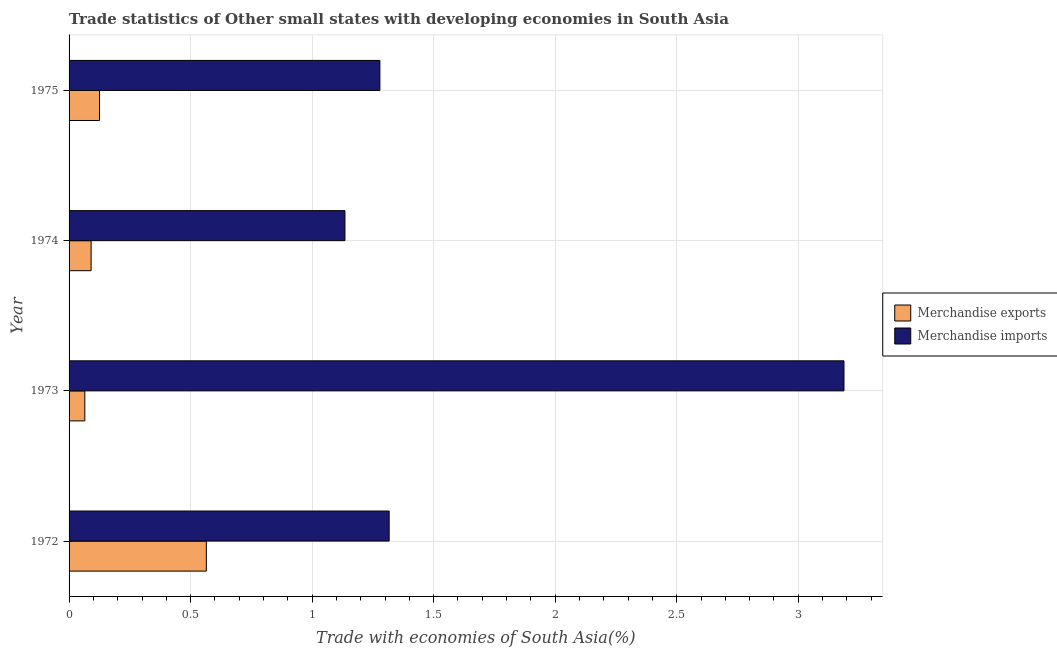How many different coloured bars are there?
Make the answer very short. 2. How many groups of bars are there?
Your response must be concise. 4. Are the number of bars per tick equal to the number of legend labels?
Ensure brevity in your answer.  Yes. How many bars are there on the 4th tick from the bottom?
Offer a terse response. 2. What is the label of the 2nd group of bars from the top?
Ensure brevity in your answer.  1974. In how many cases, is the number of bars for a given year not equal to the number of legend labels?
Provide a succinct answer. 0. What is the merchandise exports in 1973?
Provide a succinct answer. 0.06. Across all years, what is the maximum merchandise imports?
Provide a succinct answer. 3.19. Across all years, what is the minimum merchandise exports?
Make the answer very short. 0.06. In which year was the merchandise exports minimum?
Keep it short and to the point. 1973. What is the total merchandise exports in the graph?
Provide a short and direct response. 0.85. What is the difference between the merchandise imports in 1973 and that in 1974?
Make the answer very short. 2.05. What is the difference between the merchandise imports in 1974 and the merchandise exports in 1972?
Your answer should be very brief. 0.57. What is the average merchandise imports per year?
Give a very brief answer. 1.73. In the year 1974, what is the difference between the merchandise exports and merchandise imports?
Give a very brief answer. -1.04. In how many years, is the merchandise imports greater than 1.5 %?
Provide a succinct answer. 1. What is the ratio of the merchandise imports in 1974 to that in 1975?
Your answer should be very brief. 0.89. Is the difference between the merchandise imports in 1972 and 1973 greater than the difference between the merchandise exports in 1972 and 1973?
Provide a short and direct response. No. What is the difference between the highest and the second highest merchandise imports?
Keep it short and to the point. 1.87. What is the difference between the highest and the lowest merchandise imports?
Offer a very short reply. 2.05. Is the sum of the merchandise exports in 1972 and 1975 greater than the maximum merchandise imports across all years?
Offer a very short reply. No. What does the 1st bar from the top in 1975 represents?
Keep it short and to the point. Merchandise imports. How many bars are there?
Keep it short and to the point. 8. Are all the bars in the graph horizontal?
Your answer should be compact. Yes. How many years are there in the graph?
Give a very brief answer. 4. Does the graph contain any zero values?
Provide a succinct answer. No. Does the graph contain grids?
Ensure brevity in your answer.  Yes. How are the legend labels stacked?
Give a very brief answer. Vertical. What is the title of the graph?
Offer a terse response. Trade statistics of Other small states with developing economies in South Asia. Does "Broad money growth" appear as one of the legend labels in the graph?
Your answer should be very brief. No. What is the label or title of the X-axis?
Offer a terse response. Trade with economies of South Asia(%). What is the label or title of the Y-axis?
Keep it short and to the point. Year. What is the Trade with economies of South Asia(%) of Merchandise exports in 1972?
Provide a short and direct response. 0.56. What is the Trade with economies of South Asia(%) in Merchandise imports in 1972?
Your answer should be compact. 1.32. What is the Trade with economies of South Asia(%) of Merchandise exports in 1973?
Offer a very short reply. 0.06. What is the Trade with economies of South Asia(%) of Merchandise imports in 1973?
Make the answer very short. 3.19. What is the Trade with economies of South Asia(%) in Merchandise exports in 1974?
Your answer should be very brief. 0.09. What is the Trade with economies of South Asia(%) of Merchandise imports in 1974?
Offer a terse response. 1.13. What is the Trade with economies of South Asia(%) in Merchandise exports in 1975?
Your response must be concise. 0.13. What is the Trade with economies of South Asia(%) of Merchandise imports in 1975?
Your response must be concise. 1.28. Across all years, what is the maximum Trade with economies of South Asia(%) in Merchandise exports?
Provide a succinct answer. 0.56. Across all years, what is the maximum Trade with economies of South Asia(%) in Merchandise imports?
Offer a terse response. 3.19. Across all years, what is the minimum Trade with economies of South Asia(%) in Merchandise exports?
Offer a very short reply. 0.06. Across all years, what is the minimum Trade with economies of South Asia(%) in Merchandise imports?
Your answer should be compact. 1.13. What is the total Trade with economies of South Asia(%) in Merchandise exports in the graph?
Offer a terse response. 0.85. What is the total Trade with economies of South Asia(%) in Merchandise imports in the graph?
Your answer should be very brief. 6.92. What is the difference between the Trade with economies of South Asia(%) in Merchandise imports in 1972 and that in 1973?
Offer a terse response. -1.87. What is the difference between the Trade with economies of South Asia(%) of Merchandise exports in 1972 and that in 1974?
Your answer should be compact. 0.47. What is the difference between the Trade with economies of South Asia(%) of Merchandise imports in 1972 and that in 1974?
Your answer should be very brief. 0.18. What is the difference between the Trade with economies of South Asia(%) in Merchandise exports in 1972 and that in 1975?
Your response must be concise. 0.44. What is the difference between the Trade with economies of South Asia(%) in Merchandise imports in 1972 and that in 1975?
Your answer should be compact. 0.04. What is the difference between the Trade with economies of South Asia(%) of Merchandise exports in 1973 and that in 1974?
Ensure brevity in your answer.  -0.03. What is the difference between the Trade with economies of South Asia(%) of Merchandise imports in 1973 and that in 1974?
Your answer should be very brief. 2.05. What is the difference between the Trade with economies of South Asia(%) in Merchandise exports in 1973 and that in 1975?
Make the answer very short. -0.06. What is the difference between the Trade with economies of South Asia(%) in Merchandise imports in 1973 and that in 1975?
Ensure brevity in your answer.  1.91. What is the difference between the Trade with economies of South Asia(%) in Merchandise exports in 1974 and that in 1975?
Provide a succinct answer. -0.03. What is the difference between the Trade with economies of South Asia(%) in Merchandise imports in 1974 and that in 1975?
Your answer should be very brief. -0.14. What is the difference between the Trade with economies of South Asia(%) in Merchandise exports in 1972 and the Trade with economies of South Asia(%) in Merchandise imports in 1973?
Offer a very short reply. -2.62. What is the difference between the Trade with economies of South Asia(%) in Merchandise exports in 1972 and the Trade with economies of South Asia(%) in Merchandise imports in 1974?
Provide a succinct answer. -0.57. What is the difference between the Trade with economies of South Asia(%) of Merchandise exports in 1972 and the Trade with economies of South Asia(%) of Merchandise imports in 1975?
Make the answer very short. -0.71. What is the difference between the Trade with economies of South Asia(%) in Merchandise exports in 1973 and the Trade with economies of South Asia(%) in Merchandise imports in 1974?
Your answer should be very brief. -1.07. What is the difference between the Trade with economies of South Asia(%) in Merchandise exports in 1973 and the Trade with economies of South Asia(%) in Merchandise imports in 1975?
Your response must be concise. -1.21. What is the difference between the Trade with economies of South Asia(%) of Merchandise exports in 1974 and the Trade with economies of South Asia(%) of Merchandise imports in 1975?
Keep it short and to the point. -1.19. What is the average Trade with economies of South Asia(%) of Merchandise exports per year?
Offer a terse response. 0.21. What is the average Trade with economies of South Asia(%) of Merchandise imports per year?
Your answer should be very brief. 1.73. In the year 1972, what is the difference between the Trade with economies of South Asia(%) of Merchandise exports and Trade with economies of South Asia(%) of Merchandise imports?
Provide a short and direct response. -0.75. In the year 1973, what is the difference between the Trade with economies of South Asia(%) in Merchandise exports and Trade with economies of South Asia(%) in Merchandise imports?
Offer a very short reply. -3.12. In the year 1974, what is the difference between the Trade with economies of South Asia(%) in Merchandise exports and Trade with economies of South Asia(%) in Merchandise imports?
Ensure brevity in your answer.  -1.04. In the year 1975, what is the difference between the Trade with economies of South Asia(%) of Merchandise exports and Trade with economies of South Asia(%) of Merchandise imports?
Provide a succinct answer. -1.15. What is the ratio of the Trade with economies of South Asia(%) of Merchandise exports in 1972 to that in 1973?
Make the answer very short. 8.72. What is the ratio of the Trade with economies of South Asia(%) in Merchandise imports in 1972 to that in 1973?
Offer a very short reply. 0.41. What is the ratio of the Trade with economies of South Asia(%) of Merchandise exports in 1972 to that in 1974?
Offer a terse response. 6.23. What is the ratio of the Trade with economies of South Asia(%) of Merchandise imports in 1972 to that in 1974?
Keep it short and to the point. 1.16. What is the ratio of the Trade with economies of South Asia(%) of Merchandise exports in 1972 to that in 1975?
Make the answer very short. 4.51. What is the ratio of the Trade with economies of South Asia(%) in Merchandise imports in 1972 to that in 1975?
Your response must be concise. 1.03. What is the ratio of the Trade with economies of South Asia(%) in Merchandise exports in 1973 to that in 1974?
Provide a succinct answer. 0.71. What is the ratio of the Trade with economies of South Asia(%) of Merchandise imports in 1973 to that in 1974?
Provide a succinct answer. 2.81. What is the ratio of the Trade with economies of South Asia(%) of Merchandise exports in 1973 to that in 1975?
Offer a terse response. 0.52. What is the ratio of the Trade with economies of South Asia(%) in Merchandise imports in 1973 to that in 1975?
Provide a short and direct response. 2.49. What is the ratio of the Trade with economies of South Asia(%) in Merchandise exports in 1974 to that in 1975?
Your response must be concise. 0.72. What is the ratio of the Trade with economies of South Asia(%) in Merchandise imports in 1974 to that in 1975?
Keep it short and to the point. 0.89. What is the difference between the highest and the second highest Trade with economies of South Asia(%) of Merchandise exports?
Provide a short and direct response. 0.44. What is the difference between the highest and the second highest Trade with economies of South Asia(%) in Merchandise imports?
Provide a succinct answer. 1.87. What is the difference between the highest and the lowest Trade with economies of South Asia(%) in Merchandise exports?
Keep it short and to the point. 0.5. What is the difference between the highest and the lowest Trade with economies of South Asia(%) in Merchandise imports?
Provide a succinct answer. 2.05. 